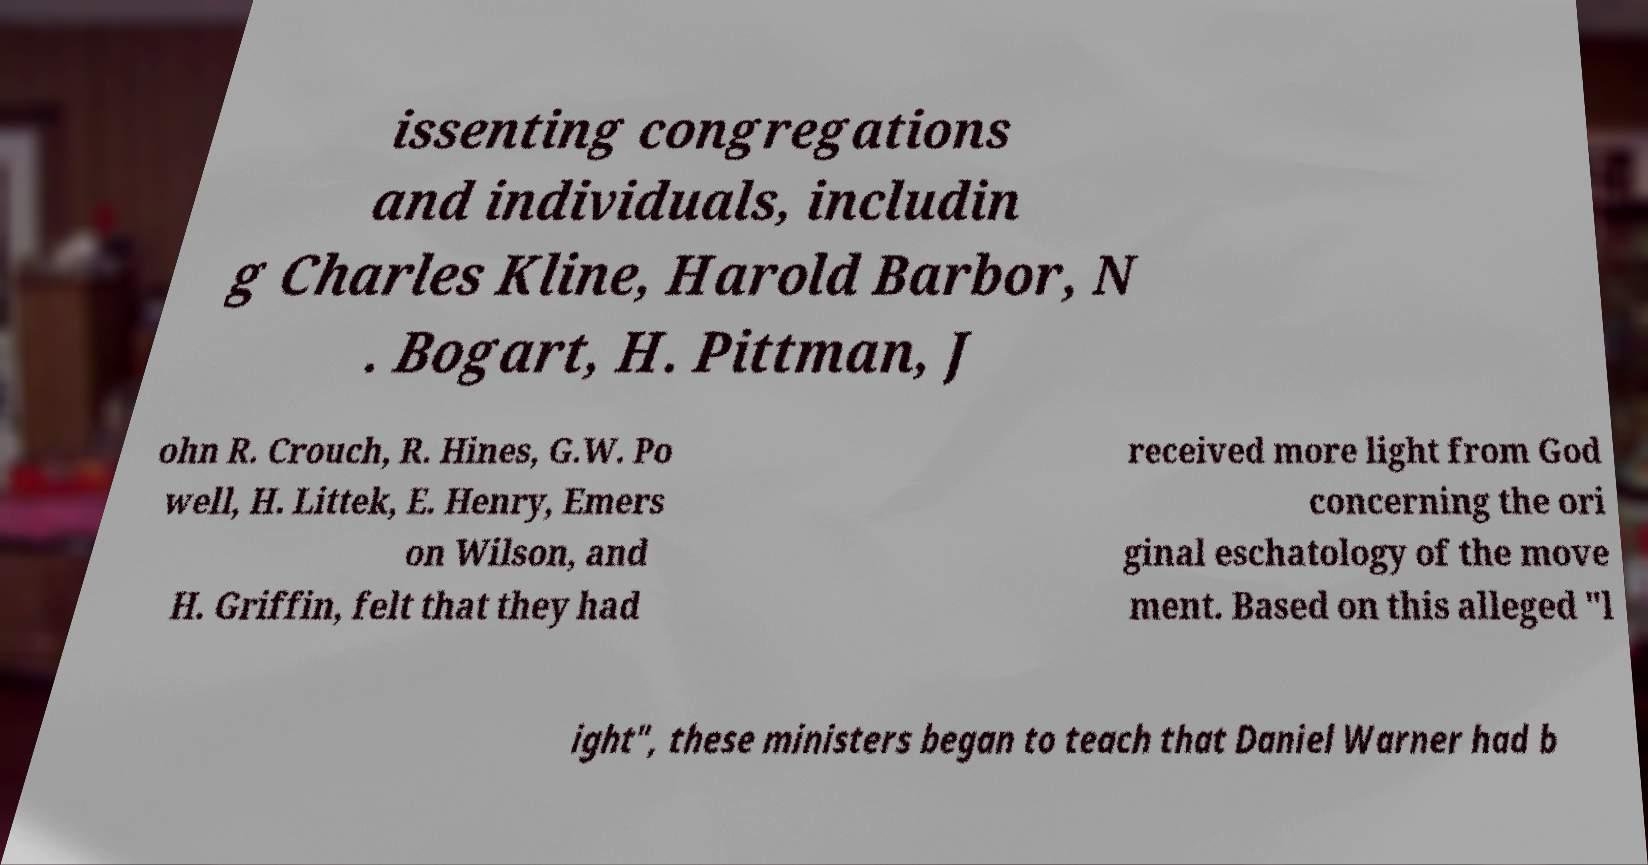I need the written content from this picture converted into text. Can you do that? issenting congregations and individuals, includin g Charles Kline, Harold Barbor, N . Bogart, H. Pittman, J ohn R. Crouch, R. Hines, G.W. Po well, H. Littek, E. Henry, Emers on Wilson, and H. Griffin, felt that they had received more light from God concerning the ori ginal eschatology of the move ment. Based on this alleged "l ight", these ministers began to teach that Daniel Warner had b 